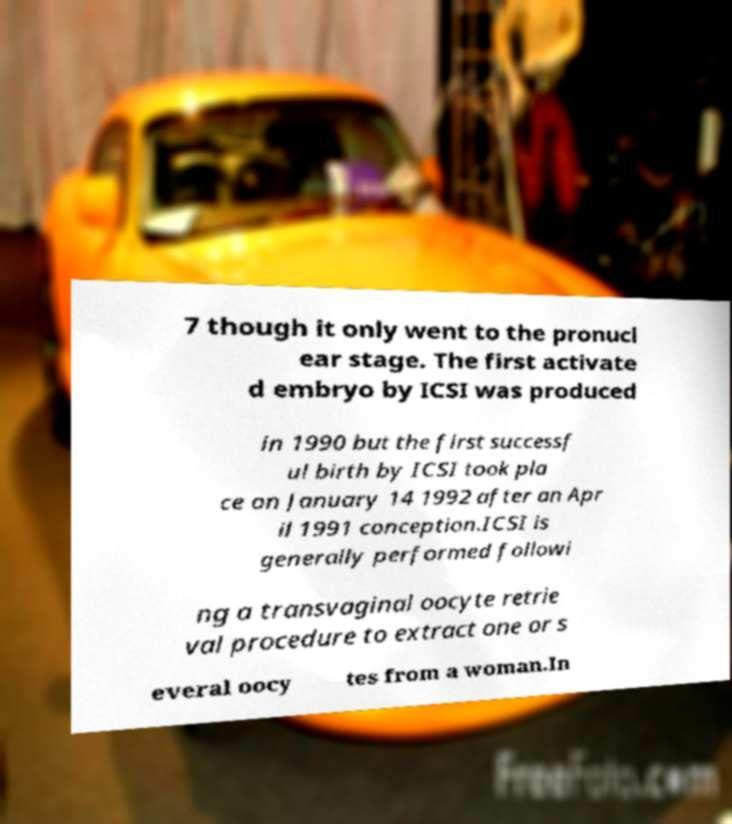Could you extract and type out the text from this image? 7 though it only went to the pronucl ear stage. The first activate d embryo by ICSI was produced in 1990 but the first successf ul birth by ICSI took pla ce on January 14 1992 after an Apr il 1991 conception.ICSI is generally performed followi ng a transvaginal oocyte retrie val procedure to extract one or s everal oocy tes from a woman.In 